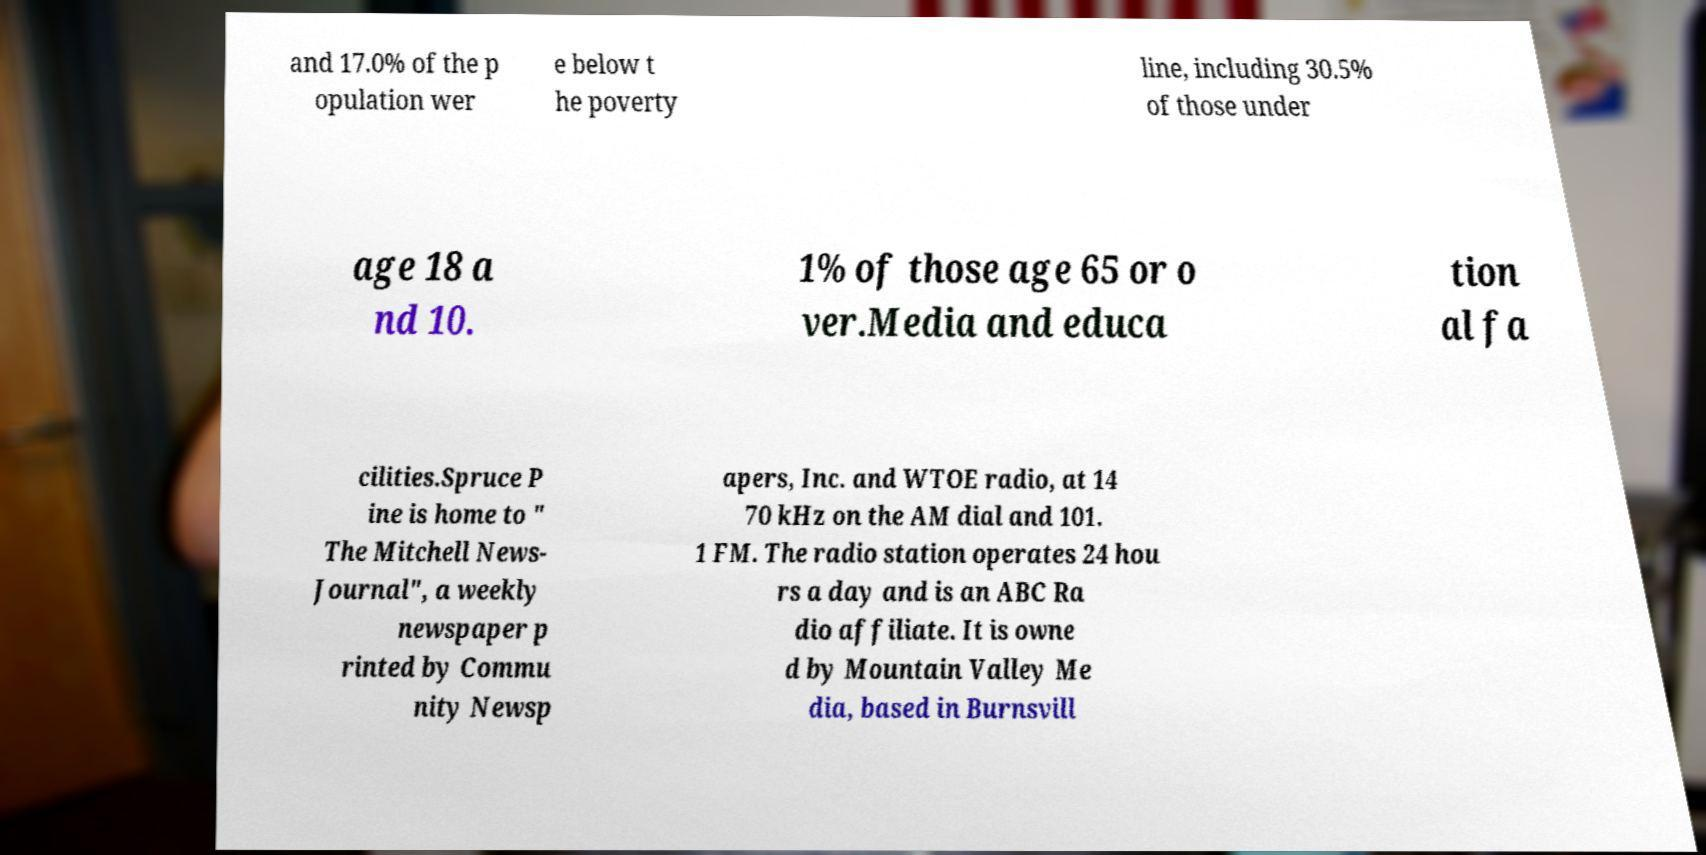What messages or text are displayed in this image? I need them in a readable, typed format. and 17.0% of the p opulation wer e below t he poverty line, including 30.5% of those under age 18 a nd 10. 1% of those age 65 or o ver.Media and educa tion al fa cilities.Spruce P ine is home to " The Mitchell News- Journal", a weekly newspaper p rinted by Commu nity Newsp apers, Inc. and WTOE radio, at 14 70 kHz on the AM dial and 101. 1 FM. The radio station operates 24 hou rs a day and is an ABC Ra dio affiliate. It is owne d by Mountain Valley Me dia, based in Burnsvill 